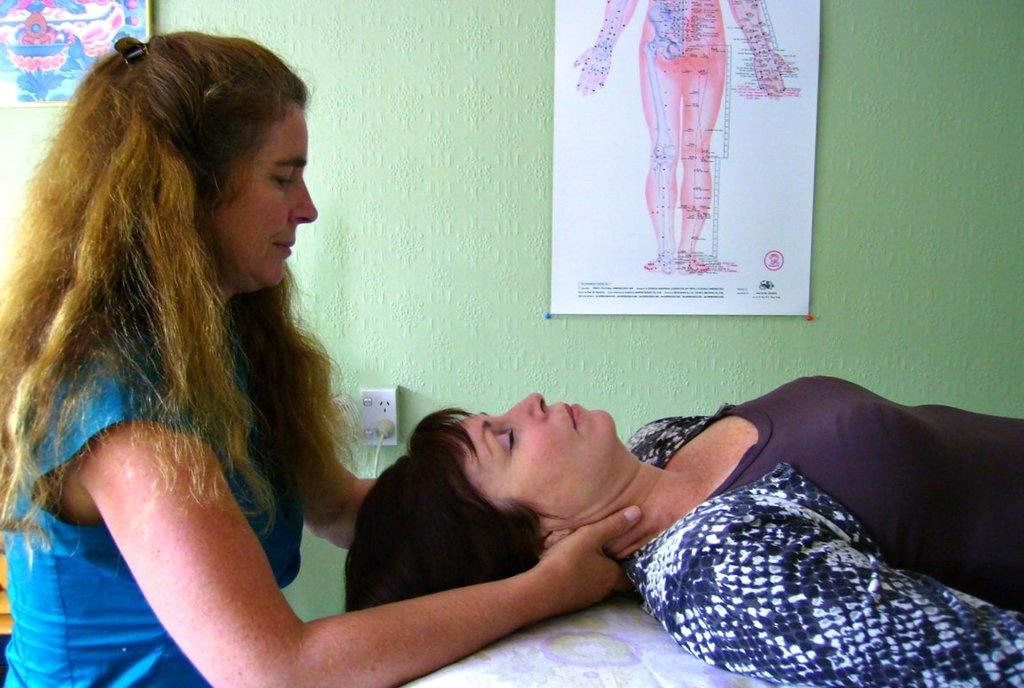How many women are in the image? There are two women in the image. What is the position of the woman on the right? The woman on the right is lying down. What color is the wall in the background? The wall in the background is green-colored. What is attached to the wall in the background? There are boards on the wall in the background. What type of dust can be seen on the cup in the image? There is no cup present in the image, so it is not possible to determine if there is any dust on it. 